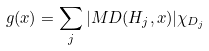<formula> <loc_0><loc_0><loc_500><loc_500>g ( x ) = \sum _ { j } | M D ( H _ { j } , x ) | \chi _ { D _ { j } }</formula> 